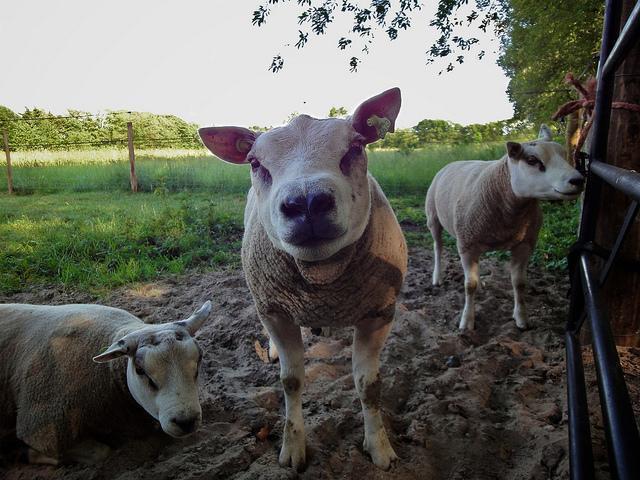Which indoor domestic animal does the center sheep resemble?
From the following four choices, select the correct answer to address the question.
Options: Bull terrier, reptile, cat, fish. Bull terrier. How many weird looking sheeps are standing on top of the dirt pile?
Select the accurate answer and provide justification: `Answer: choice
Rationale: srationale.`
Options: Two, three, four, one. Answer: three.
Rationale: One of the three sheep is not standing. 